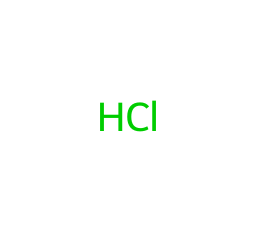What is the molecular formula of hydrochloric acid? The SMILES representation [H]Cl indicates that hydrochloric acid consists of one hydrogen atom and one chlorine atom. Therefore, the molecular formula is derived from this information.
Answer: HCl How many atoms are present in hydrochloric acid? By examining the SMILES representation, we can identify two distinct atoms: one hydrogen and one chlorine. Thus, there is a total of two atoms.
Answer: 2 What is the main characteristic of hydrochloric acid? Hydrochloric acid is a strong acid, which is characterized by its ability to dissociate completely in water, leading to a high concentration of hydrogen ions in solution.
Answer: strong How many bonds are present in the hydrochloric acid molecule? In the SMILES representation, there is one connection between the hydrogen atom and the chlorine atom, which denotes a single covalent bond. Therefore, there is one bond present.
Answer: 1 What type of acid is hydrochloric acid? Hydrochloric acid is classified as a mineral acid due to its inorganic composition, as it is derived from a non-organic source and has strong dissociating properties.
Answer: mineral What is a common use for hydrochloric acid in daily products? Hydrochloric acid is commonly found in cleaning products due to its effectiveness in removing rust and mineral deposits.
Answer: cleaning What is the pH level of a diluted solution of hydrochloric acid? Depending on its concentration, a diluted solution of hydrochloric acid typically has a pH level of around 1 to 3, indicating high acidity.
Answer: 1-3 